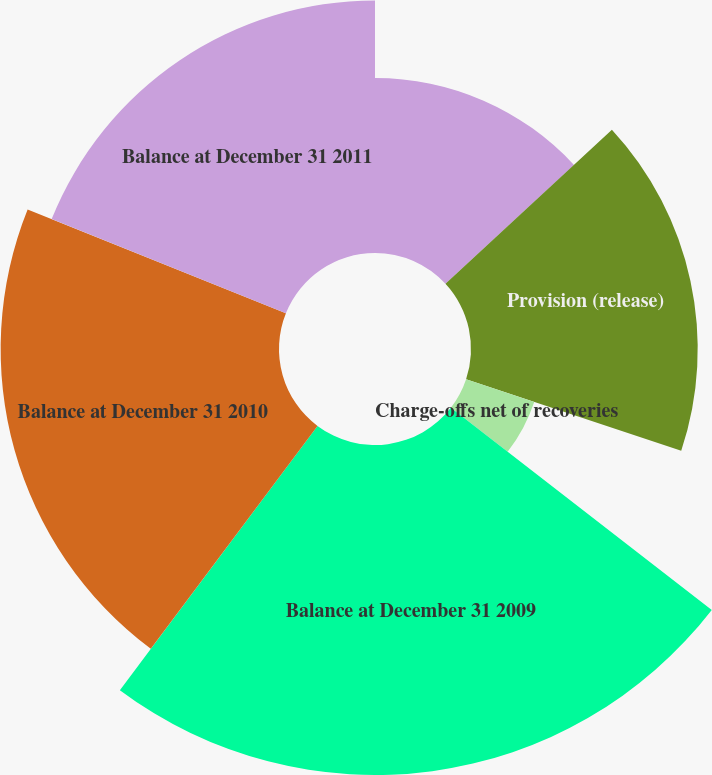Convert chart. <chart><loc_0><loc_0><loc_500><loc_500><pie_chart><fcel>Balance at January 1 2009<fcel>Provision (release)<fcel>Charge-offs net of recoveries<fcel>Balance at December 31 2009<fcel>Balance at December 31 2010<fcel>Balance at December 31 2011<nl><fcel>13.12%<fcel>16.99%<fcel>5.38%<fcel>24.73%<fcel>20.86%<fcel>18.92%<nl></chart> 